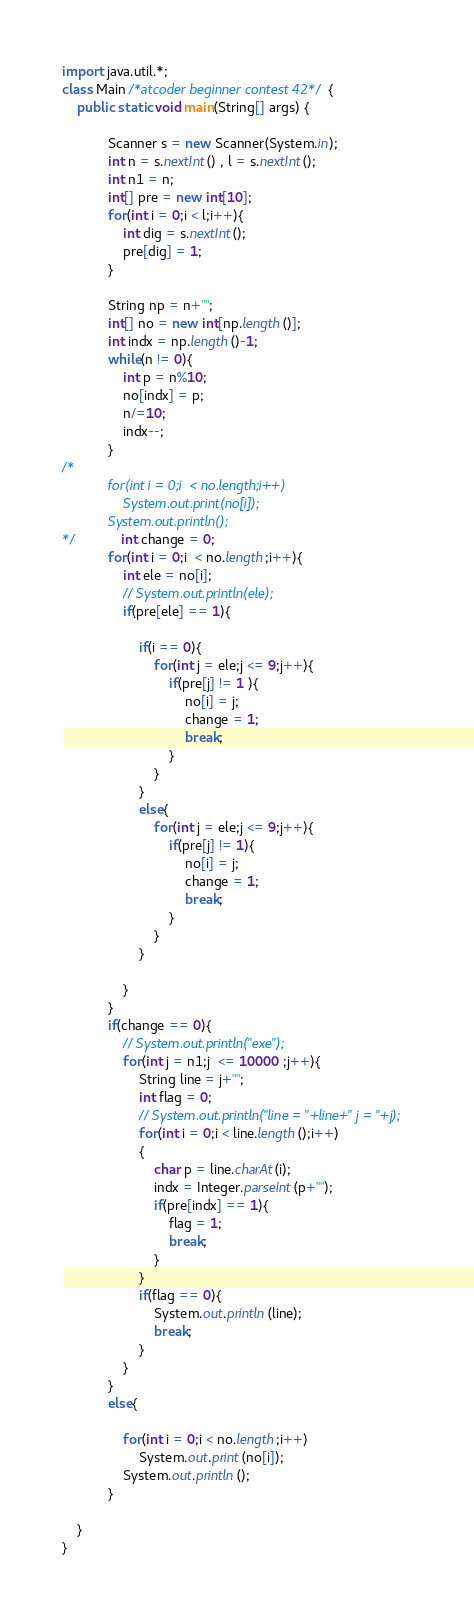<code> <loc_0><loc_0><loc_500><loc_500><_Java_>import java.util.*;
class Main /*atcoder beginner contest 42*/{
	public static void main(String[] args) {
			
			Scanner s = new Scanner(System.in);
			int n = s.nextInt() , l = s.nextInt();
			int n1 = n;
			int[] pre = new int[10];
			for(int i = 0;i < l;i++){
				int dig = s.nextInt();
				pre[dig] = 1;
			}

			String np = n+"";
			int[] no = new int[np.length()];
			int indx = np.length()-1;
			while(n != 0){
				int p = n%10;
				no[indx] = p;
				n/=10;
				indx--;
			}
/*
			for(int i = 0;i  < no.length;i++)
				System.out.print(no[i]);
			System.out.println();
*/			int change = 0;
			for(int i = 0;i  < no.length;i++){
				int ele = no[i];
				// System.out.println(ele);
				if(pre[ele] == 1){

					if(i == 0){
						for(int j = ele;j <= 9;j++){
							if(pre[j] != 1 ){
								no[i] = j;
								change = 1;
								break;
							}
						}
					}
					else{
						for(int j = ele;j <= 9;j++){
							if(pre[j] != 1){
								no[i] = j;
								change = 1;
								break;
							}
						}
					}

				}
			}
			if(change == 0){
				// System.out.println("exe");
				for(int j = n1;j  <= 10000 ;j++){
					String line = j+"";
					int flag = 0;
					// System.out.println("line = "+line+" j = "+j);
					for(int i = 0;i < line.length();i++)
					{
						char p = line.charAt(i);
						indx = Integer.parseInt(p+"");
						if(pre[indx] == 1){
							flag = 1;
							break;
						}
					}
					if(flag == 0){
						System.out.println(line);
						break;
					}
				}
			}
			else{

				for(int i = 0;i < no.length;i++)
					System.out.print(no[i]);
				System.out.println();
			}

	}
}</code> 